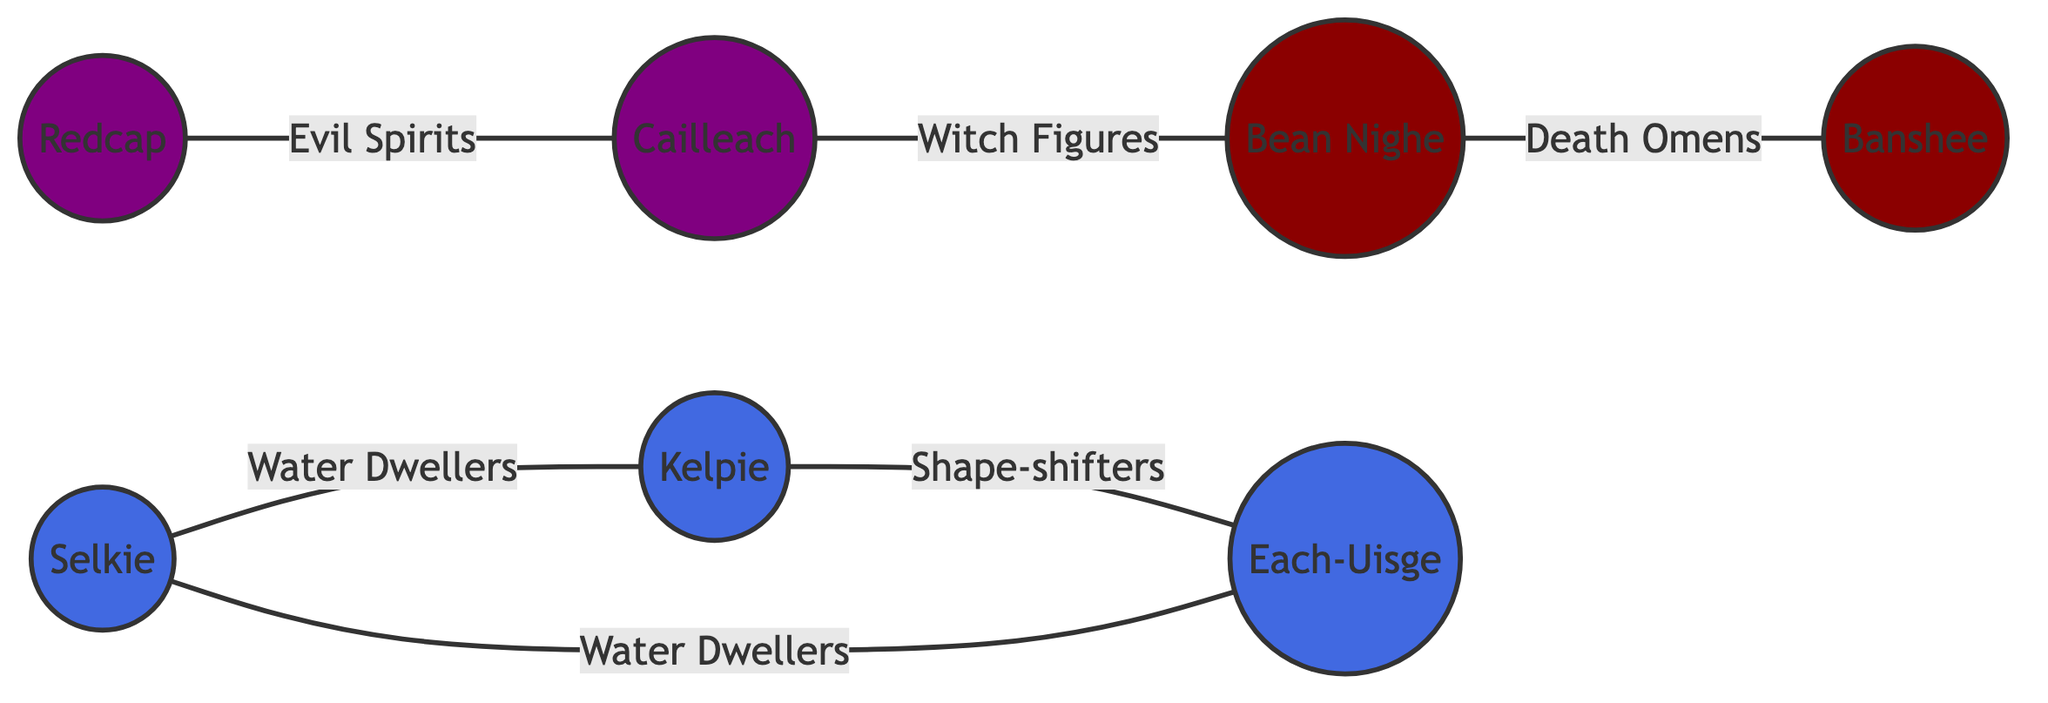What are the total number of nodes in the diagram? Counting all the unique mythological creatures represented in the nodes, we find there are seven distinct creatures: Selkie, Kelpie, Banshee, Redcap, Bean Nighe, Each-Uisge, and Cailleach.
Answer: 7 Which two creatures are connected by the relationship "Death Omens"? The edge labeled "Death Omens" connects Bean Nighe and Banshee. Both of these nodes represent figures associated with death omens in Scottish folklore.
Answer: Bean Nighe and Banshee What is the relationship between Selkie and Each-Uisge? The relationship between Selkie and Each-Uisge is labeled as "Water Dwellers", which indicates both creatures are associated with water.
Answer: Water Dwellers How many connections does Kelpie have? Kelpie is connected to two different nodes: Selkie and Each-Uisge, indicating it has two connections.
Answer: 2 Which creature is categorized as an "Evil Spirit" in the diagram? The node labeled Redcap is categorized as an "Evil Spirit", which is defined by its connection with Cailleach.
Answer: Redcap Which two creatures have a relationship that involves "Witch Figures"? The relationship labeled "Witch Figures" is between Cailleach and Bean Nighe, indicating their connection in the context of witchcraft in folklore.
Answer: Cailleach and Bean Nighe How many relationships are illustrated in the graph? Counting the edges in the graph, there are six distinct relationships connecting the various creatures, which represents the interactions described.
Answer: 6 Which of the following creatures does not interact directly with Banshee? In the diagram, the Banshee only connects to Bean Nighe, meaning Kelpie, Redcap, Cailleach, and Each-Uisge do not have a direct connection to Banshee. Therefore, options like Kelpie are valid.
Answer: Kelpie 